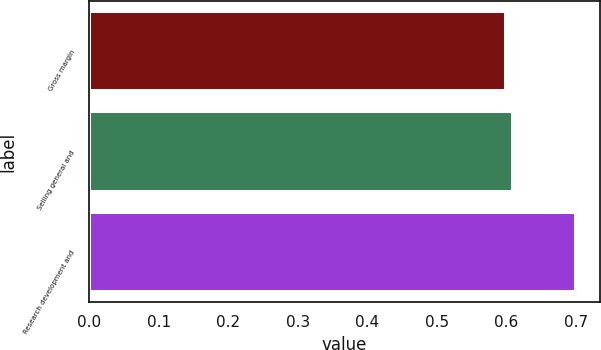Convert chart to OTSL. <chart><loc_0><loc_0><loc_500><loc_500><bar_chart><fcel>Gross margin<fcel>Selling general and<fcel>Research development and<nl><fcel>0.6<fcel>0.61<fcel>0.7<nl></chart> 